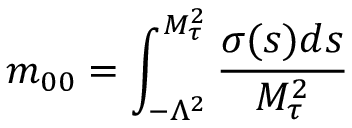Convert formula to latex. <formula><loc_0><loc_0><loc_500><loc_500>m _ { 0 0 } = \int _ { - \Lambda ^ { 2 } } ^ { M _ { \tau } ^ { 2 } } \frac { \sigma ( s ) d s } { M _ { \tau } ^ { 2 } }</formula> 